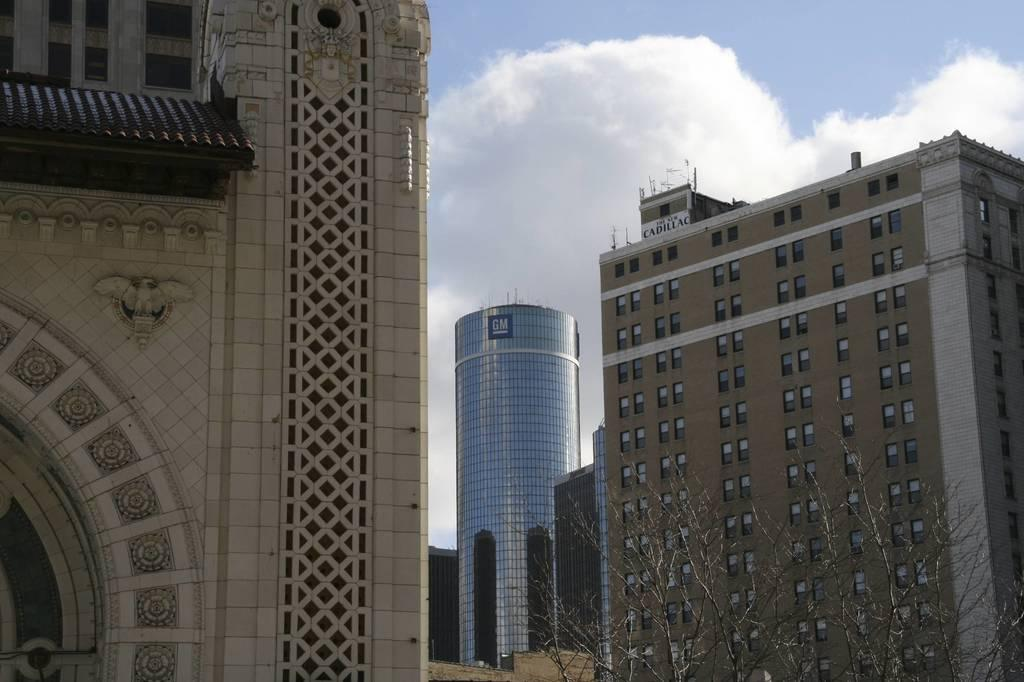What type of structures can be seen in the image? There are buildings in the image. What can be seen in the background of the image? The sky is visible in the background of the image. Where is the tree located in the image? The tree is in the bottom right corner of the image. What type of pen is visible in the image? There is no pen present in the image. 